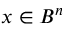<formula> <loc_0><loc_0><loc_500><loc_500>x \in B ^ { n }</formula> 